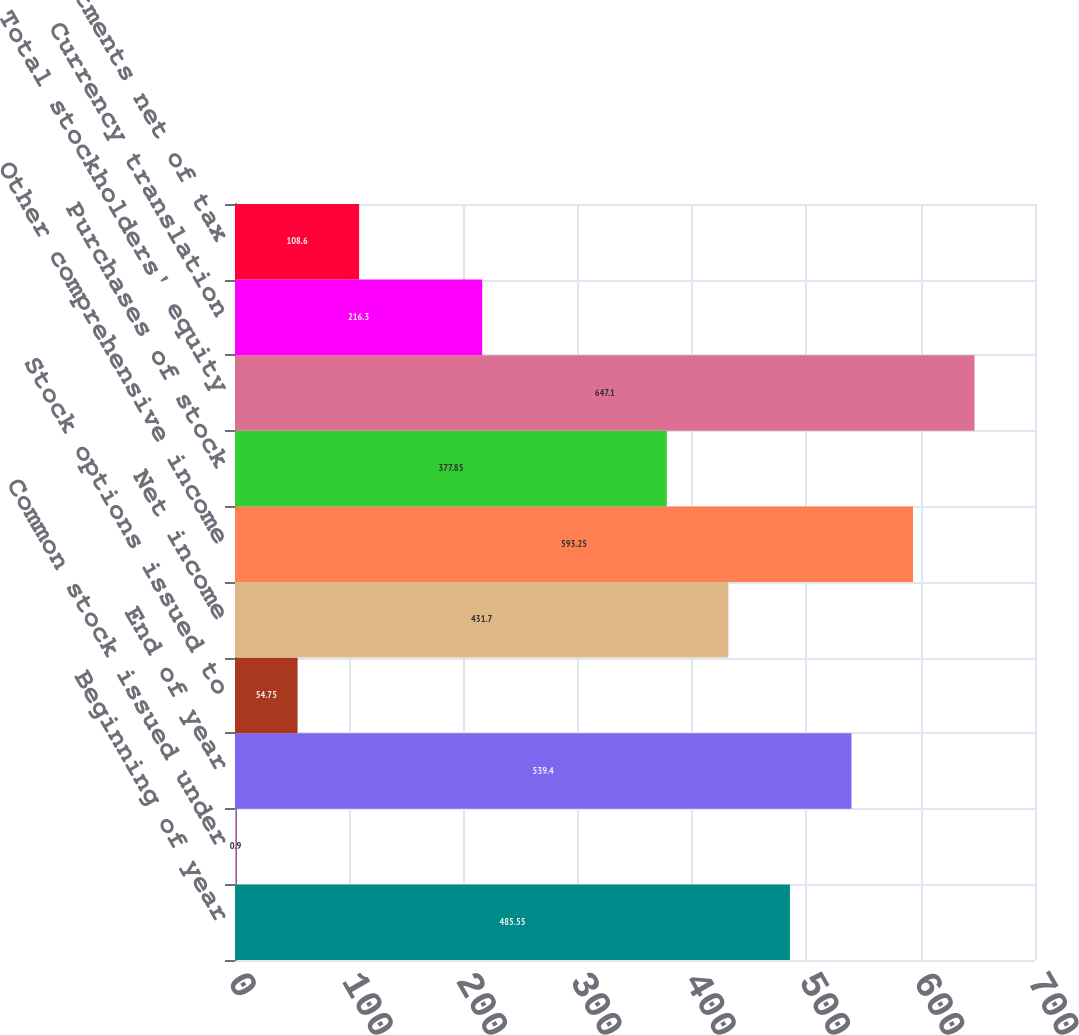Convert chart to OTSL. <chart><loc_0><loc_0><loc_500><loc_500><bar_chart><fcel>Beginning of year<fcel>Common stock issued under<fcel>End of year<fcel>Stock options issued to<fcel>Net income<fcel>Other comprehensive income<fcel>Purchases of stock<fcel>Total stockholders' equity<fcel>Currency translation<fcel>Pension adjustments net of tax<nl><fcel>485.55<fcel>0.9<fcel>539.4<fcel>54.75<fcel>431.7<fcel>593.25<fcel>377.85<fcel>647.1<fcel>216.3<fcel>108.6<nl></chart> 